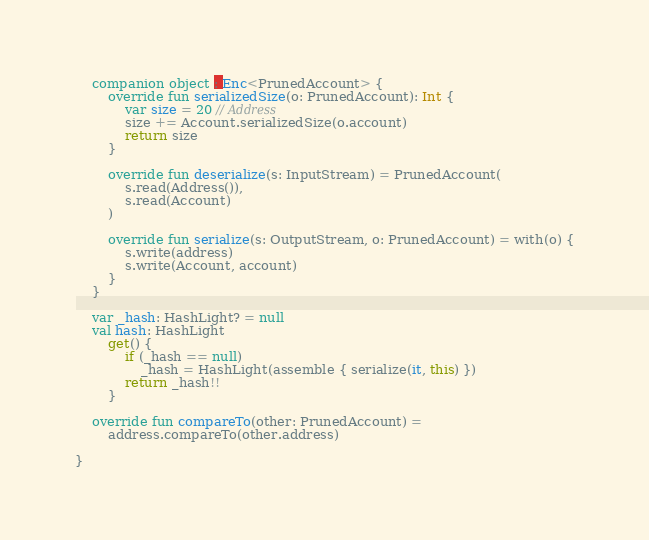<code> <loc_0><loc_0><loc_500><loc_500><_Kotlin_>    companion object : Enc<PrunedAccount> {
        override fun serializedSize(o: PrunedAccount): Int {
            var size = 20 // Address
            size += Account.serializedSize(o.account)
            return size
        }

        override fun deserialize(s: InputStream) = PrunedAccount(
            s.read(Address()),
            s.read(Account)
        )

        override fun serialize(s: OutputStream, o: PrunedAccount) = with(o) {
            s.write(address)
            s.write(Account, account)
        }
    }

    var _hash: HashLight? = null
    val hash: HashLight
        get() {
            if (_hash == null)
                _hash = HashLight(assemble { serialize(it, this) })
            return _hash!!
        }

    override fun compareTo(other: PrunedAccount) =
        address.compareTo(other.address)

}</code> 